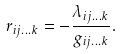Convert formula to latex. <formula><loc_0><loc_0><loc_500><loc_500>r _ { i j \dots k } = - \frac { \lambda _ { i j \dots k } } { g _ { i j \dots k } } .</formula> 